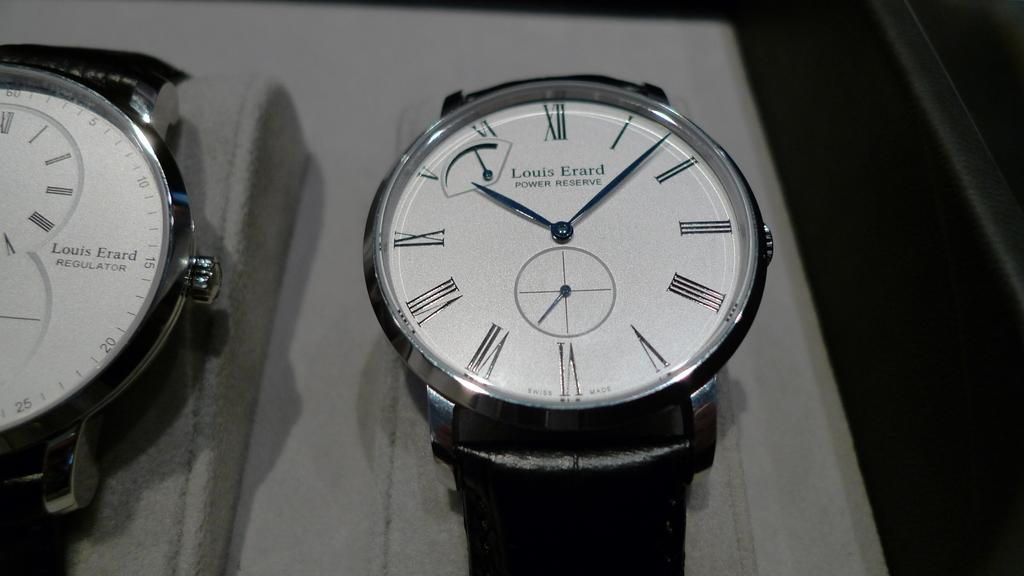<image>
Summarize the visual content of the image. The black watch with a white dial is a Louis Erard Power Reserve. 